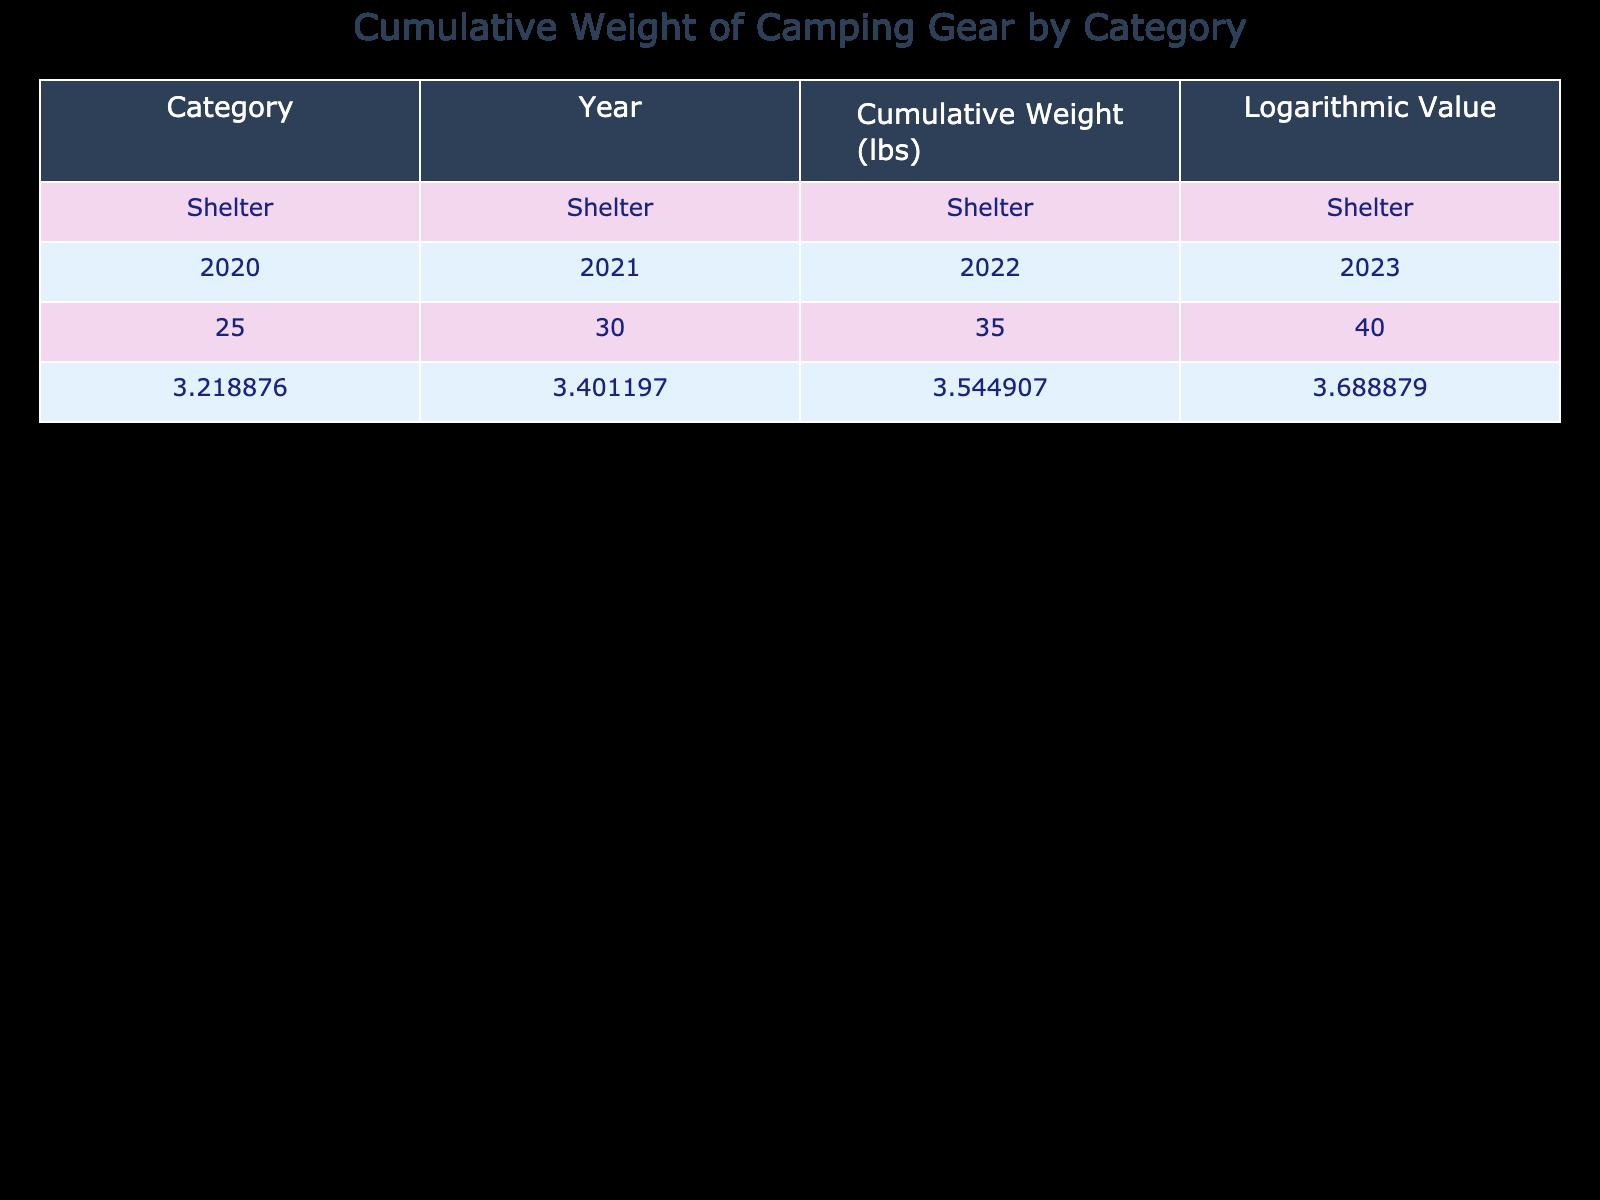What is the cumulative weight of Cooking Gear in 2023? The table shows the cumulative weight of Cooking Gear specifically listed under the year 2023. Referring to that row, the weight is 18 lbs.
Answer: 18 lbs What was the cumulative weight of Sleeping Gear in 2022? Looking at the table, we find the Sleeping Gear category for the year 2022, which indicates a cumulative weight of 25 lbs.
Answer: 25 lbs Is the cumulative weight of Clothing Gear greater than the cumulative weight of Cooking Gear in 2021? For Clothing Gear in 2021, the cumulative weight is 15 lbs, and for Cooking Gear in the same year, it is 12 lbs. Since 15 lbs is greater than 12 lbs, the statement is true.
Answer: Yes What is the difference in cumulative weight of Shelter Gear between 2020 and 2023? The cumulative weight for Shelter in 2020 is 25 lbs, and in 2023 it is 40 lbs. The difference is calculated as 40 lbs - 25 lbs = 15 lbs.
Answer: 15 lbs What year saw the highest cumulative weight for Navigation gear? Checking the Navigation category across the years, the weights listed are 5 lbs (2020), 8 lbs (2021), 10 lbs (2022), and 12 lbs (2023). The highest is 12 lbs in 2023.
Answer: 2023 What is the average cumulative weight of Sleeping Gear from 2020 to 2023? The cumulative weights for Sleeping Gear from 2020 to 2023 are 15 lbs, 20 lbs, 25 lbs, and 30 lbs, respectively. The sum is 15 + 20 + 25 + 30 = 90 lbs. Dividing by the number of years (4) gives an average of 90 lbs / 4 = 22.5 lbs.
Answer: 22.5 lbs Are the cumulative weights of Shelter Gear in 2021 and 2022 equal? The cumulative weight for Shelter Gear in 2021 is 30 lbs, and in 2022 it is 35 lbs. Since 30 lbs and 35 lbs are not equal, the statement is false.
Answer: No Which category had the least cumulative weight in 2020? Looking at the table, the cumulative weights in 2020 are: Shelter - 25 lbs, Sleeping Gear - 15 lbs, Cooking Gear - 10 lbs, Clothing - 12 lbs, and Navigation - 5 lbs. The least weight is 5 lbs from the Navigation category.
Answer: Navigation What is the cumulative weight of Clothing Gear by the end of 2022? The table shows the cumulative weight of Clothing Gear for 2022, which is 17 lbs. This value can be identified directly from the table corresponding to the Clothing category for that year.
Answer: 17 lbs 